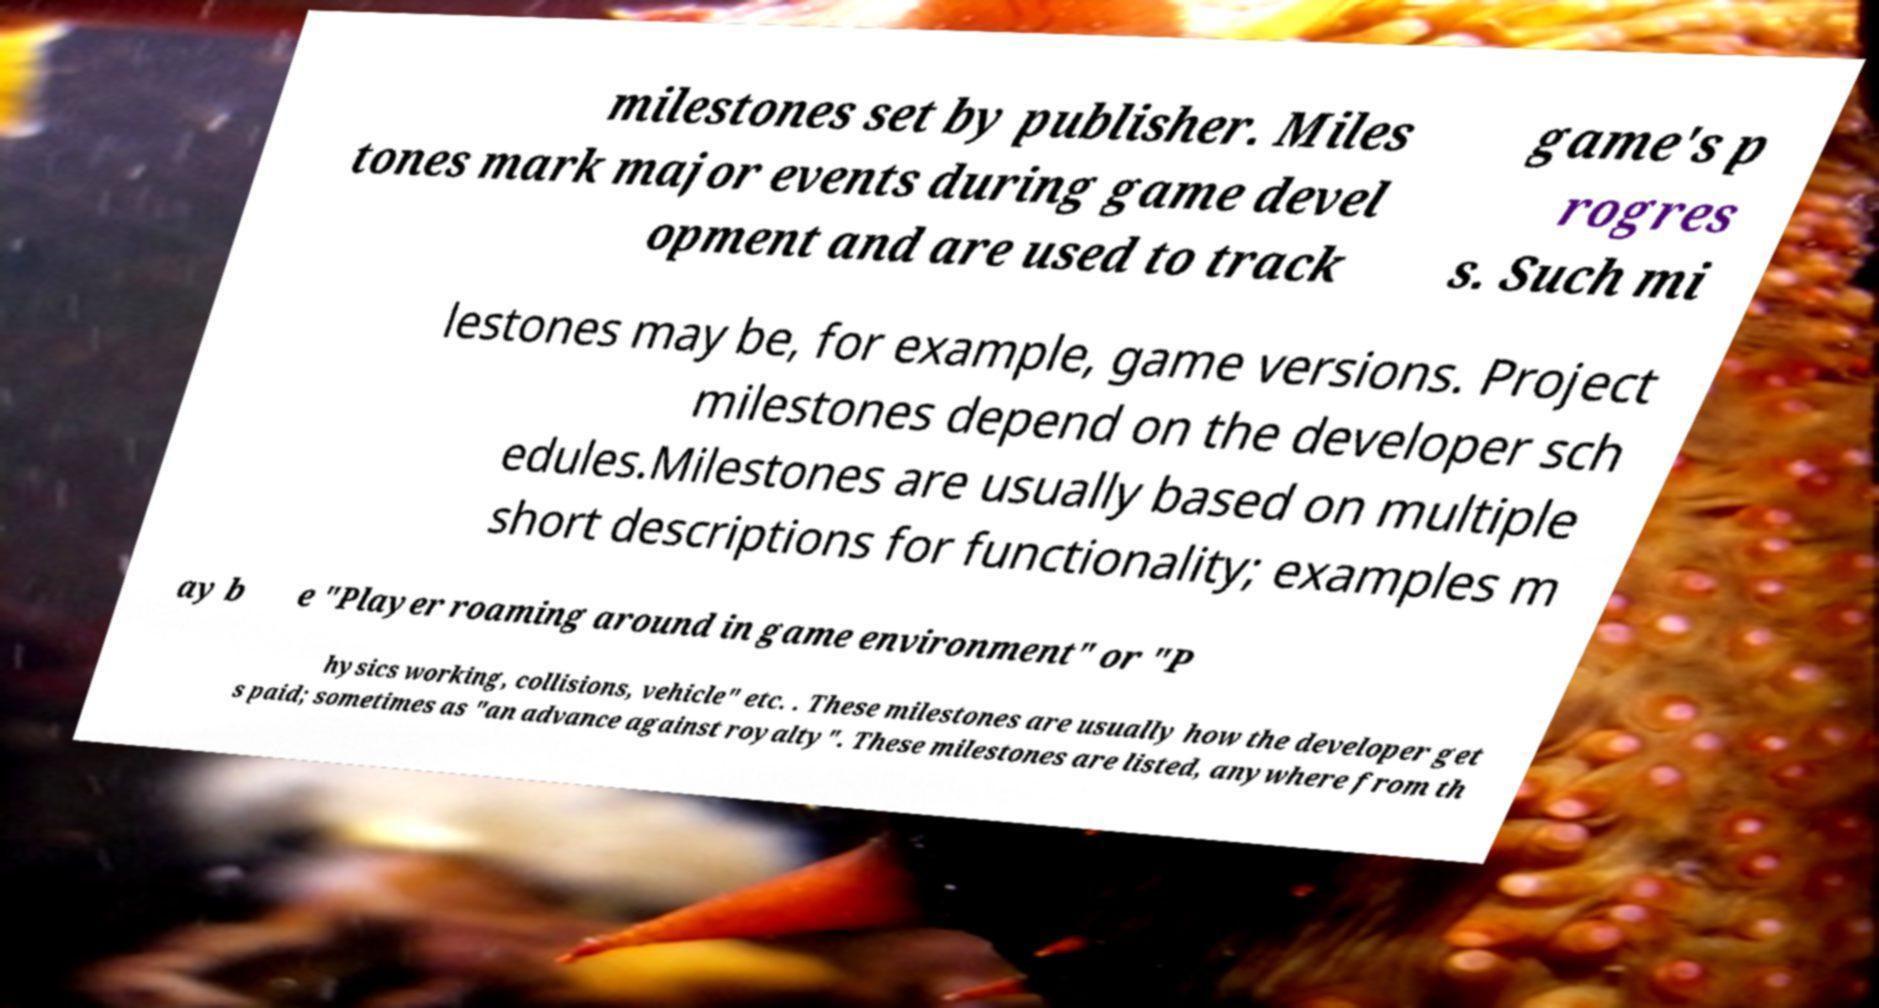Could you extract and type out the text from this image? milestones set by publisher. Miles tones mark major events during game devel opment and are used to track game's p rogres s. Such mi lestones may be, for example, game versions. Project milestones depend on the developer sch edules.Milestones are usually based on multiple short descriptions for functionality; examples m ay b e "Player roaming around in game environment" or "P hysics working, collisions, vehicle" etc. . These milestones are usually how the developer get s paid; sometimes as "an advance against royalty". These milestones are listed, anywhere from th 